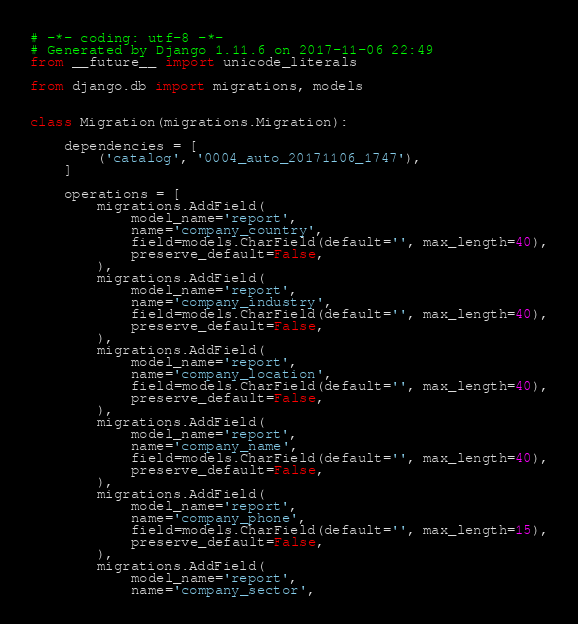<code> <loc_0><loc_0><loc_500><loc_500><_Python_># -*- coding: utf-8 -*-
# Generated by Django 1.11.6 on 2017-11-06 22:49
from __future__ import unicode_literals

from django.db import migrations, models


class Migration(migrations.Migration):

    dependencies = [
        ('catalog', '0004_auto_20171106_1747'),
    ]

    operations = [
        migrations.AddField(
            model_name='report',
            name='company_country',
            field=models.CharField(default='', max_length=40),
            preserve_default=False,
        ),
        migrations.AddField(
            model_name='report',
            name='company_industry',
            field=models.CharField(default='', max_length=40),
            preserve_default=False,
        ),
        migrations.AddField(
            model_name='report',
            name='company_location',
            field=models.CharField(default='', max_length=40),
            preserve_default=False,
        ),
        migrations.AddField(
            model_name='report',
            name='company_name',
            field=models.CharField(default='', max_length=40),
            preserve_default=False,
        ),
        migrations.AddField(
            model_name='report',
            name='company_phone',
            field=models.CharField(default='', max_length=15),
            preserve_default=False,
        ),
        migrations.AddField(
            model_name='report',
            name='company_sector',</code> 